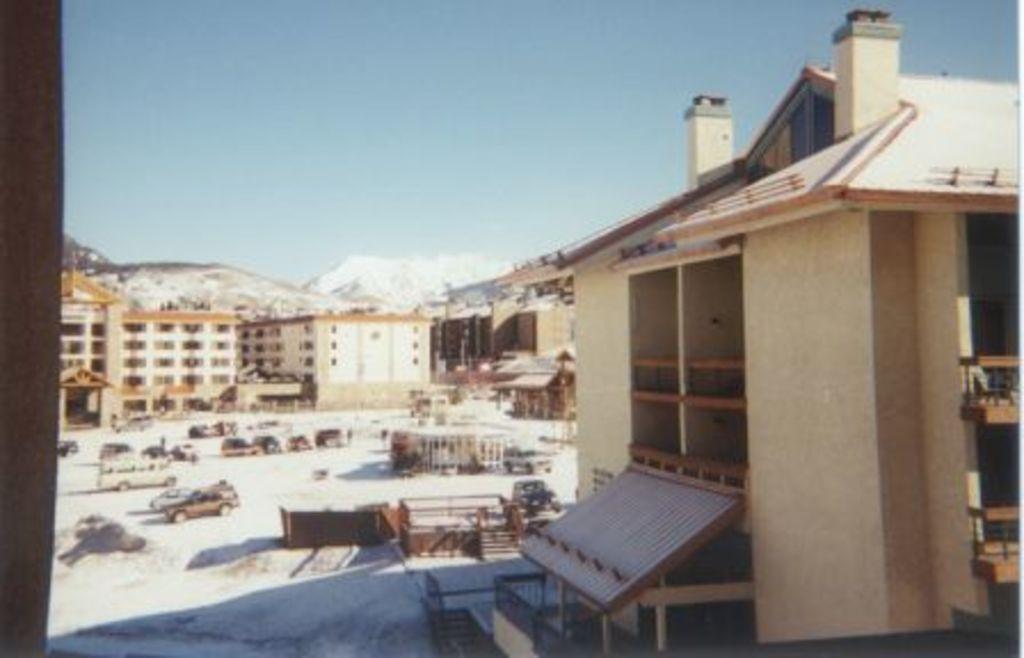Describe this image in one or two sentences. In this image there are so many buildings, mountains and some vehicles at the middle in a ground around that there are some other things. 